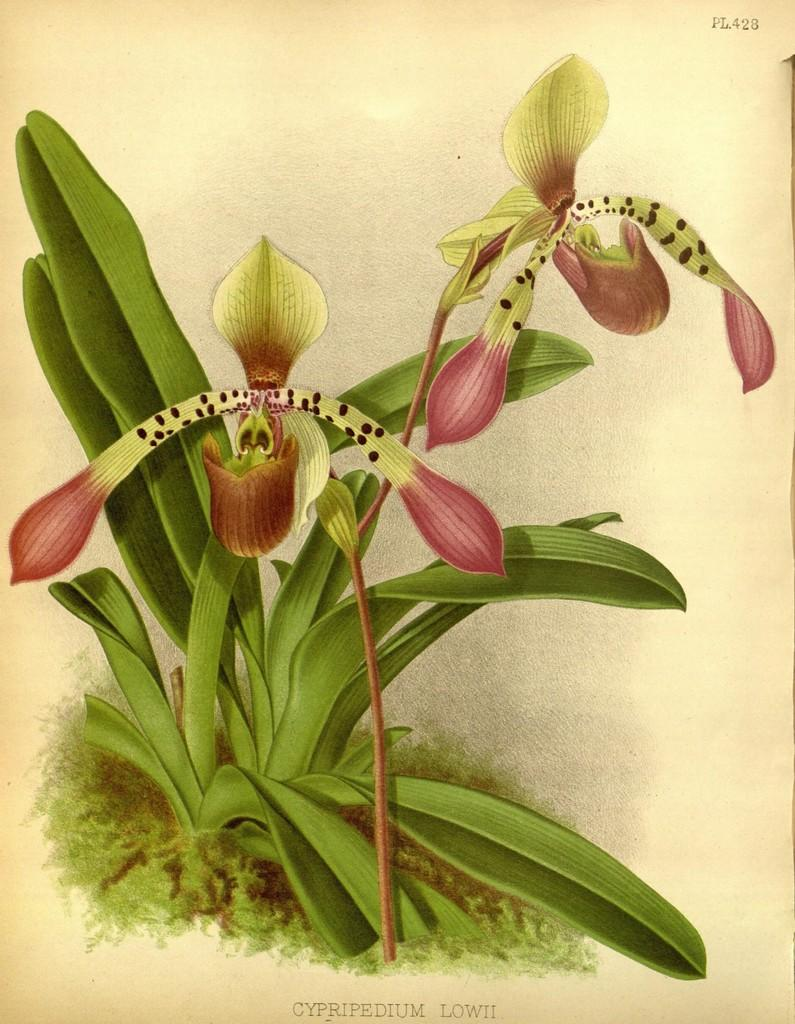What type of plant life is visible in the image? There are flowers, buds, and leaves visible in the image. Can you describe the stem in the image? It appears to be a stem in the image. What is present on top of the image? There is text on top of the image. What is present at the bottom of the image? There is text at the bottom of the image. What type of leather is used to create the humorous cause in the image? There is no leather, humor, or cause present in the image; it features plant life with text on top and bottom. 